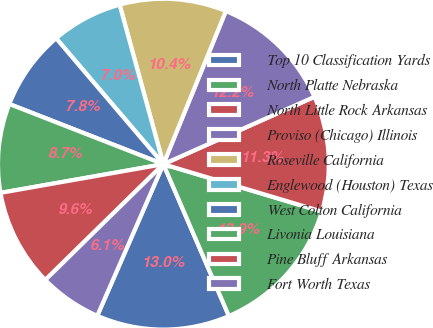Convert chart to OTSL. <chart><loc_0><loc_0><loc_500><loc_500><pie_chart><fcel>Top 10 Classification Yards<fcel>North Platte Nebraska<fcel>North Little Rock Arkansas<fcel>Proviso (Chicago) Illinois<fcel>Roseville California<fcel>Englewood (Houston) Texas<fcel>West Colton California<fcel>Livonia Louisiana<fcel>Pine Bluff Arkansas<fcel>Fort Worth Texas<nl><fcel>13.03%<fcel>13.89%<fcel>11.3%<fcel>12.16%<fcel>10.43%<fcel>6.97%<fcel>7.84%<fcel>8.7%<fcel>9.57%<fcel>6.11%<nl></chart> 